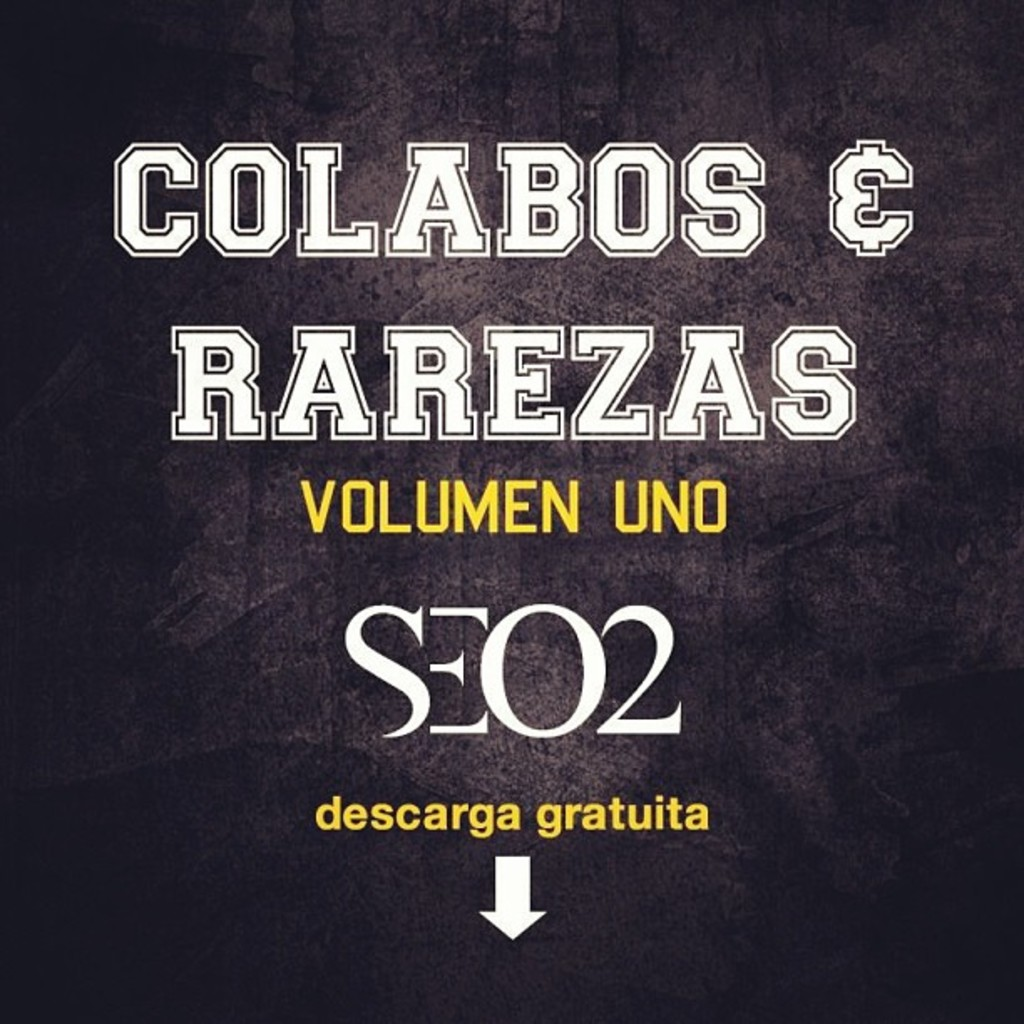What do you think is going on in this snapshot? The image appears to be the cover art for an album called "Colabos & Rarezas Volumen Uno" by the artist SEO2. The cover art sports a rugged, industrial look with a textured black background, complemented by striking white and yellow text. The layout is strategically designed, placing the album title prominently at the top, the artist's name in the middle, and 'descarga gratuita' (free download) featured at the bottom, emphasized by a bold arrow pointing downwards. This not only visually anchors the design but also enticingly suggests that the album can be downloaded without charge. The bold, sans-serif font enhances readability and adds a contemporary feel to the cover. 